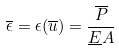<formula> <loc_0><loc_0><loc_500><loc_500>\overline { \epsilon } = \epsilon ( \overline { u } ) = \frac { \overline { P } } { \underline { E } A }</formula> 